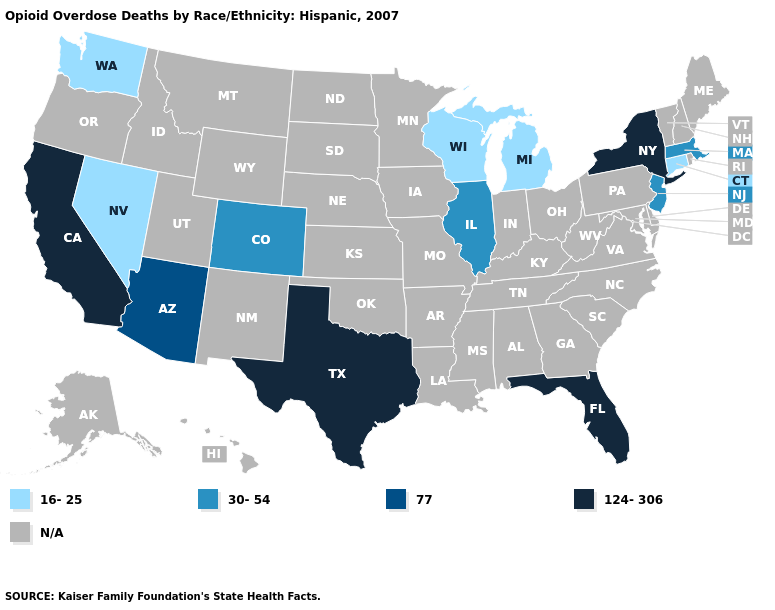What is the value of New Mexico?
Quick response, please. N/A. Which states have the lowest value in the South?
Short answer required. Florida, Texas. Name the states that have a value in the range 16-25?
Be succinct. Connecticut, Michigan, Nevada, Washington, Wisconsin. Is the legend a continuous bar?
Concise answer only. No. What is the lowest value in the USA?
Short answer required. 16-25. What is the value of Pennsylvania?
Short answer required. N/A. What is the lowest value in states that border Iowa?
Keep it brief. 16-25. What is the value of Montana?
Keep it brief. N/A. Does the map have missing data?
Quick response, please. Yes. What is the value of Ohio?
Keep it brief. N/A. What is the highest value in states that border Idaho?
Keep it brief. 16-25. Name the states that have a value in the range 16-25?
Short answer required. Connecticut, Michigan, Nevada, Washington, Wisconsin. 